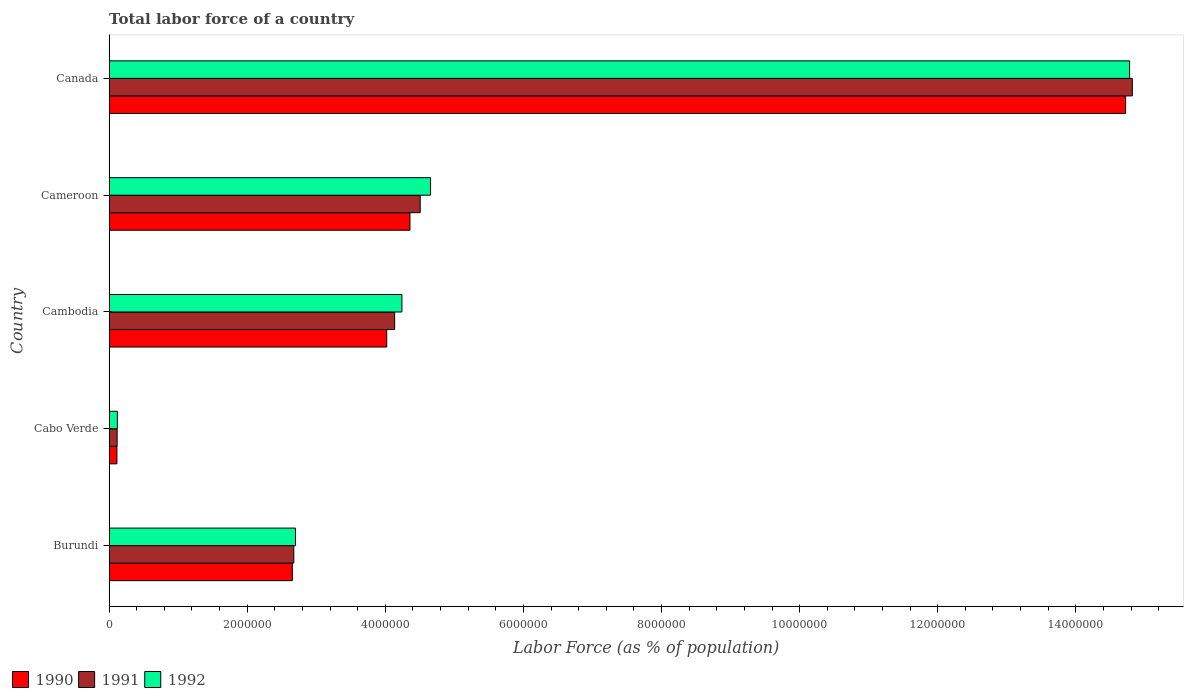How many groups of bars are there?
Keep it short and to the point. 5. Are the number of bars per tick equal to the number of legend labels?
Provide a short and direct response. Yes. How many bars are there on the 1st tick from the top?
Provide a short and direct response. 3. What is the label of the 5th group of bars from the top?
Give a very brief answer. Burundi. What is the percentage of labor force in 1991 in Cameroon?
Provide a short and direct response. 4.51e+06. Across all countries, what is the maximum percentage of labor force in 1992?
Offer a terse response. 1.48e+07. Across all countries, what is the minimum percentage of labor force in 1992?
Offer a very short reply. 1.20e+05. In which country was the percentage of labor force in 1990 maximum?
Your answer should be very brief. Canada. In which country was the percentage of labor force in 1992 minimum?
Make the answer very short. Cabo Verde. What is the total percentage of labor force in 1992 in the graph?
Make the answer very short. 2.65e+07. What is the difference between the percentage of labor force in 1990 in Cambodia and that in Cameroon?
Your response must be concise. -3.36e+05. What is the difference between the percentage of labor force in 1990 in Burundi and the percentage of labor force in 1991 in Cambodia?
Offer a terse response. -1.48e+06. What is the average percentage of labor force in 1991 per country?
Make the answer very short. 5.25e+06. What is the difference between the percentage of labor force in 1990 and percentage of labor force in 1991 in Burundi?
Give a very brief answer. -2.17e+04. In how many countries, is the percentage of labor force in 1991 greater than 6000000 %?
Make the answer very short. 1. What is the ratio of the percentage of labor force in 1990 in Cabo Verde to that in Cameroon?
Offer a very short reply. 0.03. Is the percentage of labor force in 1992 in Cambodia less than that in Canada?
Keep it short and to the point. Yes. Is the difference between the percentage of labor force in 1990 in Cambodia and Canada greater than the difference between the percentage of labor force in 1991 in Cambodia and Canada?
Provide a succinct answer. No. What is the difference between the highest and the second highest percentage of labor force in 1992?
Provide a short and direct response. 1.01e+07. What is the difference between the highest and the lowest percentage of labor force in 1992?
Offer a very short reply. 1.47e+07. Is the sum of the percentage of labor force in 1991 in Burundi and Cabo Verde greater than the maximum percentage of labor force in 1990 across all countries?
Keep it short and to the point. No. What does the 1st bar from the bottom in Cambodia represents?
Offer a very short reply. 1990. Is it the case that in every country, the sum of the percentage of labor force in 1992 and percentage of labor force in 1991 is greater than the percentage of labor force in 1990?
Offer a very short reply. Yes. How many bars are there?
Keep it short and to the point. 15. Are all the bars in the graph horizontal?
Provide a succinct answer. Yes. What is the difference between two consecutive major ticks on the X-axis?
Your answer should be compact. 2.00e+06. Are the values on the major ticks of X-axis written in scientific E-notation?
Your response must be concise. No. Does the graph contain any zero values?
Offer a terse response. No. Does the graph contain grids?
Offer a very short reply. No. What is the title of the graph?
Your answer should be very brief. Total labor force of a country. Does "1975" appear as one of the legend labels in the graph?
Keep it short and to the point. No. What is the label or title of the X-axis?
Provide a succinct answer. Labor Force (as % of population). What is the label or title of the Y-axis?
Provide a short and direct response. Country. What is the Labor Force (as % of population) of 1990 in Burundi?
Ensure brevity in your answer.  2.65e+06. What is the Labor Force (as % of population) of 1991 in Burundi?
Give a very brief answer. 2.68e+06. What is the Labor Force (as % of population) in 1992 in Burundi?
Ensure brevity in your answer.  2.70e+06. What is the Labor Force (as % of population) of 1990 in Cabo Verde?
Ensure brevity in your answer.  1.14e+05. What is the Labor Force (as % of population) in 1991 in Cabo Verde?
Provide a short and direct response. 1.17e+05. What is the Labor Force (as % of population) in 1992 in Cabo Verde?
Offer a terse response. 1.20e+05. What is the Labor Force (as % of population) of 1990 in Cambodia?
Ensure brevity in your answer.  4.02e+06. What is the Labor Force (as % of population) in 1991 in Cambodia?
Provide a succinct answer. 4.14e+06. What is the Labor Force (as % of population) of 1992 in Cambodia?
Provide a succinct answer. 4.24e+06. What is the Labor Force (as % of population) of 1990 in Cameroon?
Provide a short and direct response. 4.36e+06. What is the Labor Force (as % of population) of 1991 in Cameroon?
Your response must be concise. 4.51e+06. What is the Labor Force (as % of population) of 1992 in Cameroon?
Give a very brief answer. 4.66e+06. What is the Labor Force (as % of population) in 1990 in Canada?
Your answer should be very brief. 1.47e+07. What is the Labor Force (as % of population) of 1991 in Canada?
Your response must be concise. 1.48e+07. What is the Labor Force (as % of population) of 1992 in Canada?
Make the answer very short. 1.48e+07. Across all countries, what is the maximum Labor Force (as % of population) of 1990?
Offer a terse response. 1.47e+07. Across all countries, what is the maximum Labor Force (as % of population) of 1991?
Your answer should be very brief. 1.48e+07. Across all countries, what is the maximum Labor Force (as % of population) in 1992?
Provide a short and direct response. 1.48e+07. Across all countries, what is the minimum Labor Force (as % of population) of 1990?
Provide a short and direct response. 1.14e+05. Across all countries, what is the minimum Labor Force (as % of population) of 1991?
Give a very brief answer. 1.17e+05. Across all countries, what is the minimum Labor Force (as % of population) of 1992?
Your answer should be very brief. 1.20e+05. What is the total Labor Force (as % of population) of 1990 in the graph?
Give a very brief answer. 2.59e+07. What is the total Labor Force (as % of population) in 1991 in the graph?
Give a very brief answer. 2.63e+07. What is the total Labor Force (as % of population) of 1992 in the graph?
Provide a succinct answer. 2.65e+07. What is the difference between the Labor Force (as % of population) of 1990 in Burundi and that in Cabo Verde?
Give a very brief answer. 2.54e+06. What is the difference between the Labor Force (as % of population) of 1991 in Burundi and that in Cabo Verde?
Provide a short and direct response. 2.56e+06. What is the difference between the Labor Force (as % of population) in 1992 in Burundi and that in Cabo Verde?
Offer a very short reply. 2.58e+06. What is the difference between the Labor Force (as % of population) in 1990 in Burundi and that in Cambodia?
Provide a short and direct response. -1.37e+06. What is the difference between the Labor Force (as % of population) in 1991 in Burundi and that in Cambodia?
Ensure brevity in your answer.  -1.46e+06. What is the difference between the Labor Force (as % of population) in 1992 in Burundi and that in Cambodia?
Ensure brevity in your answer.  -1.54e+06. What is the difference between the Labor Force (as % of population) of 1990 in Burundi and that in Cameroon?
Offer a very short reply. -1.70e+06. What is the difference between the Labor Force (as % of population) in 1991 in Burundi and that in Cameroon?
Keep it short and to the point. -1.83e+06. What is the difference between the Labor Force (as % of population) in 1992 in Burundi and that in Cameroon?
Keep it short and to the point. -1.96e+06. What is the difference between the Labor Force (as % of population) in 1990 in Burundi and that in Canada?
Give a very brief answer. -1.21e+07. What is the difference between the Labor Force (as % of population) of 1991 in Burundi and that in Canada?
Offer a very short reply. -1.21e+07. What is the difference between the Labor Force (as % of population) of 1992 in Burundi and that in Canada?
Your answer should be compact. -1.21e+07. What is the difference between the Labor Force (as % of population) in 1990 in Cabo Verde and that in Cambodia?
Keep it short and to the point. -3.91e+06. What is the difference between the Labor Force (as % of population) in 1991 in Cabo Verde and that in Cambodia?
Provide a succinct answer. -4.02e+06. What is the difference between the Labor Force (as % of population) in 1992 in Cabo Verde and that in Cambodia?
Offer a terse response. -4.12e+06. What is the difference between the Labor Force (as % of population) in 1990 in Cabo Verde and that in Cameroon?
Your answer should be compact. -4.24e+06. What is the difference between the Labor Force (as % of population) in 1991 in Cabo Verde and that in Cameroon?
Offer a terse response. -4.39e+06. What is the difference between the Labor Force (as % of population) of 1992 in Cabo Verde and that in Cameroon?
Give a very brief answer. -4.54e+06. What is the difference between the Labor Force (as % of population) in 1990 in Cabo Verde and that in Canada?
Ensure brevity in your answer.  -1.46e+07. What is the difference between the Labor Force (as % of population) of 1991 in Cabo Verde and that in Canada?
Provide a succinct answer. -1.47e+07. What is the difference between the Labor Force (as % of population) in 1992 in Cabo Verde and that in Canada?
Give a very brief answer. -1.47e+07. What is the difference between the Labor Force (as % of population) of 1990 in Cambodia and that in Cameroon?
Make the answer very short. -3.36e+05. What is the difference between the Labor Force (as % of population) of 1991 in Cambodia and that in Cameroon?
Offer a terse response. -3.70e+05. What is the difference between the Labor Force (as % of population) in 1992 in Cambodia and that in Cameroon?
Make the answer very short. -4.15e+05. What is the difference between the Labor Force (as % of population) of 1990 in Cambodia and that in Canada?
Ensure brevity in your answer.  -1.07e+07. What is the difference between the Labor Force (as % of population) in 1991 in Cambodia and that in Canada?
Provide a short and direct response. -1.07e+07. What is the difference between the Labor Force (as % of population) in 1992 in Cambodia and that in Canada?
Give a very brief answer. -1.05e+07. What is the difference between the Labor Force (as % of population) in 1990 in Cameroon and that in Canada?
Offer a terse response. -1.04e+07. What is the difference between the Labor Force (as % of population) in 1991 in Cameroon and that in Canada?
Offer a terse response. -1.03e+07. What is the difference between the Labor Force (as % of population) of 1992 in Cameroon and that in Canada?
Ensure brevity in your answer.  -1.01e+07. What is the difference between the Labor Force (as % of population) in 1990 in Burundi and the Labor Force (as % of population) in 1991 in Cabo Verde?
Your response must be concise. 2.54e+06. What is the difference between the Labor Force (as % of population) in 1990 in Burundi and the Labor Force (as % of population) in 1992 in Cabo Verde?
Your answer should be very brief. 2.53e+06. What is the difference between the Labor Force (as % of population) of 1991 in Burundi and the Labor Force (as % of population) of 1992 in Cabo Verde?
Make the answer very short. 2.55e+06. What is the difference between the Labor Force (as % of population) in 1990 in Burundi and the Labor Force (as % of population) in 1991 in Cambodia?
Give a very brief answer. -1.48e+06. What is the difference between the Labor Force (as % of population) of 1990 in Burundi and the Labor Force (as % of population) of 1992 in Cambodia?
Make the answer very short. -1.59e+06. What is the difference between the Labor Force (as % of population) in 1991 in Burundi and the Labor Force (as % of population) in 1992 in Cambodia?
Offer a terse response. -1.57e+06. What is the difference between the Labor Force (as % of population) of 1990 in Burundi and the Labor Force (as % of population) of 1991 in Cameroon?
Provide a short and direct response. -1.85e+06. What is the difference between the Labor Force (as % of population) of 1990 in Burundi and the Labor Force (as % of population) of 1992 in Cameroon?
Offer a very short reply. -2.00e+06. What is the difference between the Labor Force (as % of population) in 1991 in Burundi and the Labor Force (as % of population) in 1992 in Cameroon?
Give a very brief answer. -1.98e+06. What is the difference between the Labor Force (as % of population) in 1990 in Burundi and the Labor Force (as % of population) in 1991 in Canada?
Provide a succinct answer. -1.22e+07. What is the difference between the Labor Force (as % of population) of 1990 in Burundi and the Labor Force (as % of population) of 1992 in Canada?
Keep it short and to the point. -1.21e+07. What is the difference between the Labor Force (as % of population) of 1991 in Burundi and the Labor Force (as % of population) of 1992 in Canada?
Offer a very short reply. -1.21e+07. What is the difference between the Labor Force (as % of population) of 1990 in Cabo Verde and the Labor Force (as % of population) of 1991 in Cambodia?
Ensure brevity in your answer.  -4.02e+06. What is the difference between the Labor Force (as % of population) of 1990 in Cabo Verde and the Labor Force (as % of population) of 1992 in Cambodia?
Your answer should be compact. -4.13e+06. What is the difference between the Labor Force (as % of population) of 1991 in Cabo Verde and the Labor Force (as % of population) of 1992 in Cambodia?
Provide a succinct answer. -4.12e+06. What is the difference between the Labor Force (as % of population) in 1990 in Cabo Verde and the Labor Force (as % of population) in 1991 in Cameroon?
Ensure brevity in your answer.  -4.39e+06. What is the difference between the Labor Force (as % of population) in 1990 in Cabo Verde and the Labor Force (as % of population) in 1992 in Cameroon?
Ensure brevity in your answer.  -4.54e+06. What is the difference between the Labor Force (as % of population) of 1991 in Cabo Verde and the Labor Force (as % of population) of 1992 in Cameroon?
Ensure brevity in your answer.  -4.54e+06. What is the difference between the Labor Force (as % of population) of 1990 in Cabo Verde and the Labor Force (as % of population) of 1991 in Canada?
Offer a terse response. -1.47e+07. What is the difference between the Labor Force (as % of population) of 1990 in Cabo Verde and the Labor Force (as % of population) of 1992 in Canada?
Keep it short and to the point. -1.47e+07. What is the difference between the Labor Force (as % of population) in 1991 in Cabo Verde and the Labor Force (as % of population) in 1992 in Canada?
Give a very brief answer. -1.47e+07. What is the difference between the Labor Force (as % of population) in 1990 in Cambodia and the Labor Force (as % of population) in 1991 in Cameroon?
Make the answer very short. -4.85e+05. What is the difference between the Labor Force (as % of population) in 1990 in Cambodia and the Labor Force (as % of population) in 1992 in Cameroon?
Make the answer very short. -6.35e+05. What is the difference between the Labor Force (as % of population) in 1991 in Cambodia and the Labor Force (as % of population) in 1992 in Cameroon?
Keep it short and to the point. -5.20e+05. What is the difference between the Labor Force (as % of population) of 1990 in Cambodia and the Labor Force (as % of population) of 1991 in Canada?
Your answer should be compact. -1.08e+07. What is the difference between the Labor Force (as % of population) in 1990 in Cambodia and the Labor Force (as % of population) in 1992 in Canada?
Keep it short and to the point. -1.08e+07. What is the difference between the Labor Force (as % of population) in 1991 in Cambodia and the Labor Force (as % of population) in 1992 in Canada?
Keep it short and to the point. -1.06e+07. What is the difference between the Labor Force (as % of population) in 1990 in Cameroon and the Labor Force (as % of population) in 1991 in Canada?
Your answer should be compact. -1.05e+07. What is the difference between the Labor Force (as % of population) of 1990 in Cameroon and the Labor Force (as % of population) of 1992 in Canada?
Your answer should be very brief. -1.04e+07. What is the difference between the Labor Force (as % of population) in 1991 in Cameroon and the Labor Force (as % of population) in 1992 in Canada?
Keep it short and to the point. -1.03e+07. What is the average Labor Force (as % of population) in 1990 per country?
Your answer should be very brief. 5.17e+06. What is the average Labor Force (as % of population) in 1991 per country?
Keep it short and to the point. 5.25e+06. What is the average Labor Force (as % of population) in 1992 per country?
Offer a very short reply. 5.30e+06. What is the difference between the Labor Force (as % of population) in 1990 and Labor Force (as % of population) in 1991 in Burundi?
Provide a succinct answer. -2.17e+04. What is the difference between the Labor Force (as % of population) of 1990 and Labor Force (as % of population) of 1992 in Burundi?
Keep it short and to the point. -4.64e+04. What is the difference between the Labor Force (as % of population) in 1991 and Labor Force (as % of population) in 1992 in Burundi?
Your answer should be compact. -2.47e+04. What is the difference between the Labor Force (as % of population) in 1990 and Labor Force (as % of population) in 1991 in Cabo Verde?
Your answer should be very brief. -3171. What is the difference between the Labor Force (as % of population) of 1990 and Labor Force (as % of population) of 1992 in Cabo Verde?
Ensure brevity in your answer.  -6675. What is the difference between the Labor Force (as % of population) of 1991 and Labor Force (as % of population) of 1992 in Cabo Verde?
Give a very brief answer. -3504. What is the difference between the Labor Force (as % of population) of 1990 and Labor Force (as % of population) of 1991 in Cambodia?
Ensure brevity in your answer.  -1.15e+05. What is the difference between the Labor Force (as % of population) of 1990 and Labor Force (as % of population) of 1992 in Cambodia?
Keep it short and to the point. -2.20e+05. What is the difference between the Labor Force (as % of population) in 1991 and Labor Force (as % of population) in 1992 in Cambodia?
Your answer should be very brief. -1.05e+05. What is the difference between the Labor Force (as % of population) in 1990 and Labor Force (as % of population) in 1991 in Cameroon?
Give a very brief answer. -1.48e+05. What is the difference between the Labor Force (as % of population) in 1990 and Labor Force (as % of population) in 1992 in Cameroon?
Your answer should be very brief. -2.98e+05. What is the difference between the Labor Force (as % of population) in 1991 and Labor Force (as % of population) in 1992 in Cameroon?
Your response must be concise. -1.50e+05. What is the difference between the Labor Force (as % of population) of 1990 and Labor Force (as % of population) of 1991 in Canada?
Keep it short and to the point. -9.72e+04. What is the difference between the Labor Force (as % of population) in 1990 and Labor Force (as % of population) in 1992 in Canada?
Offer a terse response. -5.76e+04. What is the difference between the Labor Force (as % of population) in 1991 and Labor Force (as % of population) in 1992 in Canada?
Offer a very short reply. 3.97e+04. What is the ratio of the Labor Force (as % of population) of 1990 in Burundi to that in Cabo Verde?
Your answer should be very brief. 23.33. What is the ratio of the Labor Force (as % of population) in 1991 in Burundi to that in Cabo Verde?
Provide a succinct answer. 22.89. What is the ratio of the Labor Force (as % of population) in 1992 in Burundi to that in Cabo Verde?
Make the answer very short. 22.42. What is the ratio of the Labor Force (as % of population) of 1990 in Burundi to that in Cambodia?
Your answer should be compact. 0.66. What is the ratio of the Labor Force (as % of population) of 1991 in Burundi to that in Cambodia?
Offer a terse response. 0.65. What is the ratio of the Labor Force (as % of population) of 1992 in Burundi to that in Cambodia?
Your answer should be very brief. 0.64. What is the ratio of the Labor Force (as % of population) in 1990 in Burundi to that in Cameroon?
Give a very brief answer. 0.61. What is the ratio of the Labor Force (as % of population) in 1991 in Burundi to that in Cameroon?
Your answer should be very brief. 0.59. What is the ratio of the Labor Force (as % of population) in 1992 in Burundi to that in Cameroon?
Ensure brevity in your answer.  0.58. What is the ratio of the Labor Force (as % of population) of 1990 in Burundi to that in Canada?
Ensure brevity in your answer.  0.18. What is the ratio of the Labor Force (as % of population) in 1991 in Burundi to that in Canada?
Your response must be concise. 0.18. What is the ratio of the Labor Force (as % of population) in 1992 in Burundi to that in Canada?
Your response must be concise. 0.18. What is the ratio of the Labor Force (as % of population) of 1990 in Cabo Verde to that in Cambodia?
Your answer should be very brief. 0.03. What is the ratio of the Labor Force (as % of population) in 1991 in Cabo Verde to that in Cambodia?
Ensure brevity in your answer.  0.03. What is the ratio of the Labor Force (as % of population) in 1992 in Cabo Verde to that in Cambodia?
Ensure brevity in your answer.  0.03. What is the ratio of the Labor Force (as % of population) in 1990 in Cabo Verde to that in Cameroon?
Offer a terse response. 0.03. What is the ratio of the Labor Force (as % of population) of 1991 in Cabo Verde to that in Cameroon?
Offer a very short reply. 0.03. What is the ratio of the Labor Force (as % of population) of 1992 in Cabo Verde to that in Cameroon?
Keep it short and to the point. 0.03. What is the ratio of the Labor Force (as % of population) of 1990 in Cabo Verde to that in Canada?
Your answer should be very brief. 0.01. What is the ratio of the Labor Force (as % of population) in 1991 in Cabo Verde to that in Canada?
Your answer should be very brief. 0.01. What is the ratio of the Labor Force (as % of population) of 1992 in Cabo Verde to that in Canada?
Ensure brevity in your answer.  0.01. What is the ratio of the Labor Force (as % of population) of 1990 in Cambodia to that in Cameroon?
Provide a short and direct response. 0.92. What is the ratio of the Labor Force (as % of population) in 1991 in Cambodia to that in Cameroon?
Your answer should be very brief. 0.92. What is the ratio of the Labor Force (as % of population) in 1992 in Cambodia to that in Cameroon?
Ensure brevity in your answer.  0.91. What is the ratio of the Labor Force (as % of population) of 1990 in Cambodia to that in Canada?
Provide a succinct answer. 0.27. What is the ratio of the Labor Force (as % of population) of 1991 in Cambodia to that in Canada?
Give a very brief answer. 0.28. What is the ratio of the Labor Force (as % of population) in 1992 in Cambodia to that in Canada?
Ensure brevity in your answer.  0.29. What is the ratio of the Labor Force (as % of population) of 1990 in Cameroon to that in Canada?
Make the answer very short. 0.3. What is the ratio of the Labor Force (as % of population) in 1991 in Cameroon to that in Canada?
Your answer should be compact. 0.3. What is the ratio of the Labor Force (as % of population) in 1992 in Cameroon to that in Canada?
Your response must be concise. 0.32. What is the difference between the highest and the second highest Labor Force (as % of population) of 1990?
Keep it short and to the point. 1.04e+07. What is the difference between the highest and the second highest Labor Force (as % of population) in 1991?
Keep it short and to the point. 1.03e+07. What is the difference between the highest and the second highest Labor Force (as % of population) of 1992?
Keep it short and to the point. 1.01e+07. What is the difference between the highest and the lowest Labor Force (as % of population) in 1990?
Offer a very short reply. 1.46e+07. What is the difference between the highest and the lowest Labor Force (as % of population) in 1991?
Make the answer very short. 1.47e+07. What is the difference between the highest and the lowest Labor Force (as % of population) in 1992?
Provide a succinct answer. 1.47e+07. 